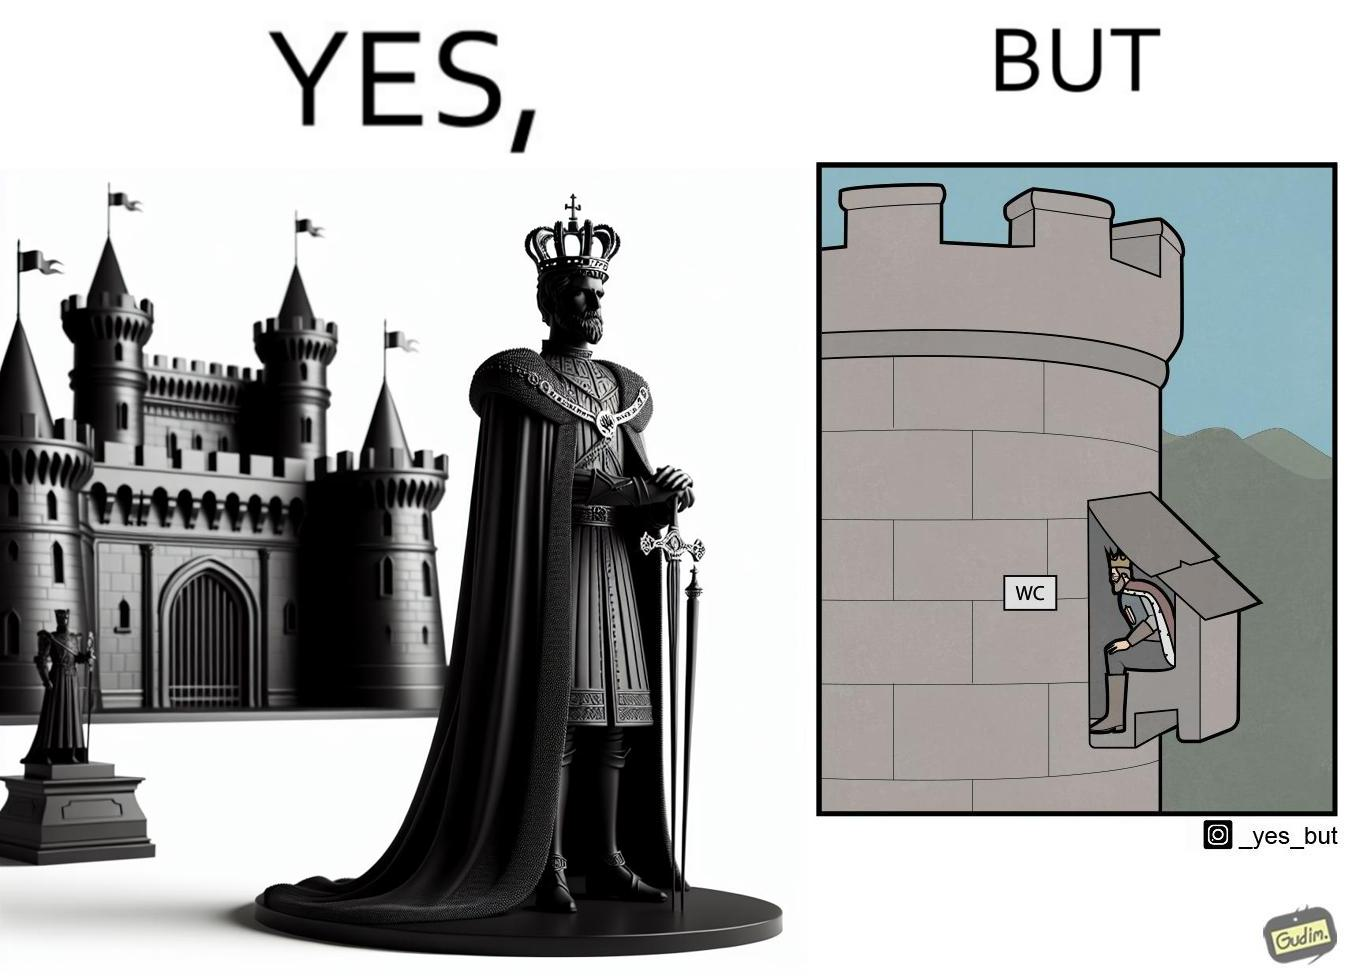Is this image satirical or non-satirical? Yes, this image is satirical. 